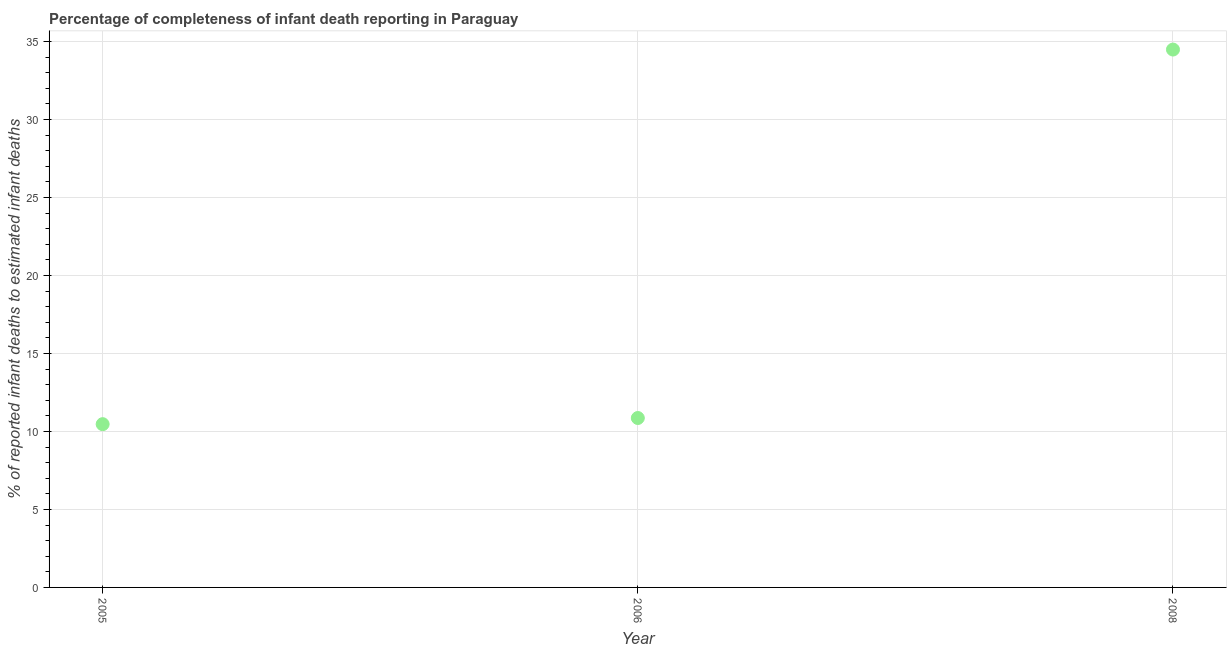What is the completeness of infant death reporting in 2008?
Offer a terse response. 34.49. Across all years, what is the maximum completeness of infant death reporting?
Ensure brevity in your answer.  34.49. Across all years, what is the minimum completeness of infant death reporting?
Ensure brevity in your answer.  10.47. What is the sum of the completeness of infant death reporting?
Your response must be concise. 55.82. What is the difference between the completeness of infant death reporting in 2005 and 2008?
Your answer should be compact. -24.02. What is the average completeness of infant death reporting per year?
Provide a succinct answer. 18.61. What is the median completeness of infant death reporting?
Give a very brief answer. 10.86. What is the ratio of the completeness of infant death reporting in 2005 to that in 2006?
Keep it short and to the point. 0.96. Is the completeness of infant death reporting in 2005 less than that in 2008?
Provide a short and direct response. Yes. What is the difference between the highest and the second highest completeness of infant death reporting?
Give a very brief answer. 23.62. What is the difference between the highest and the lowest completeness of infant death reporting?
Your answer should be compact. 24.02. In how many years, is the completeness of infant death reporting greater than the average completeness of infant death reporting taken over all years?
Offer a terse response. 1. What is the difference between two consecutive major ticks on the Y-axis?
Offer a very short reply. 5. Are the values on the major ticks of Y-axis written in scientific E-notation?
Your response must be concise. No. What is the title of the graph?
Offer a terse response. Percentage of completeness of infant death reporting in Paraguay. What is the label or title of the Y-axis?
Give a very brief answer. % of reported infant deaths to estimated infant deaths. What is the % of reported infant deaths to estimated infant deaths in 2005?
Offer a very short reply. 10.47. What is the % of reported infant deaths to estimated infant deaths in 2006?
Ensure brevity in your answer.  10.86. What is the % of reported infant deaths to estimated infant deaths in 2008?
Give a very brief answer. 34.49. What is the difference between the % of reported infant deaths to estimated infant deaths in 2005 and 2006?
Make the answer very short. -0.39. What is the difference between the % of reported infant deaths to estimated infant deaths in 2005 and 2008?
Keep it short and to the point. -24.02. What is the difference between the % of reported infant deaths to estimated infant deaths in 2006 and 2008?
Offer a very short reply. -23.62. What is the ratio of the % of reported infant deaths to estimated infant deaths in 2005 to that in 2006?
Offer a very short reply. 0.96. What is the ratio of the % of reported infant deaths to estimated infant deaths in 2005 to that in 2008?
Offer a very short reply. 0.3. What is the ratio of the % of reported infant deaths to estimated infant deaths in 2006 to that in 2008?
Ensure brevity in your answer.  0.32. 